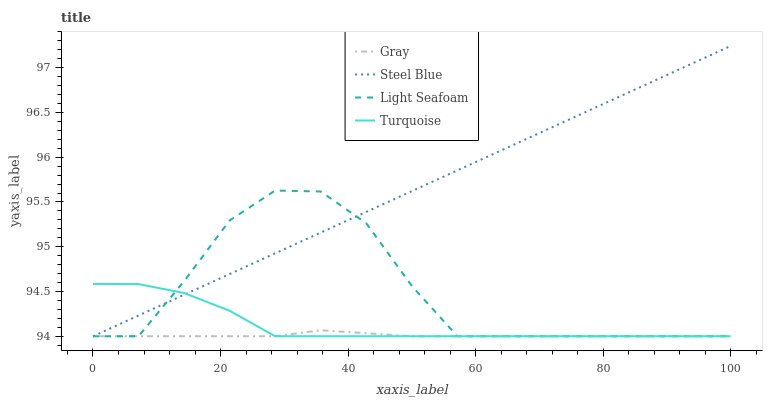Does Gray have the minimum area under the curve?
Answer yes or no. Yes. Does Steel Blue have the maximum area under the curve?
Answer yes or no. Yes. Does Turquoise have the minimum area under the curve?
Answer yes or no. No. Does Turquoise have the maximum area under the curve?
Answer yes or no. No. Is Steel Blue the smoothest?
Answer yes or no. Yes. Is Light Seafoam the roughest?
Answer yes or no. Yes. Is Turquoise the smoothest?
Answer yes or no. No. Is Turquoise the roughest?
Answer yes or no. No. Does Gray have the lowest value?
Answer yes or no. Yes. Does Steel Blue have the highest value?
Answer yes or no. Yes. Does Turquoise have the highest value?
Answer yes or no. No. Does Steel Blue intersect Gray?
Answer yes or no. Yes. Is Steel Blue less than Gray?
Answer yes or no. No. Is Steel Blue greater than Gray?
Answer yes or no. No. 